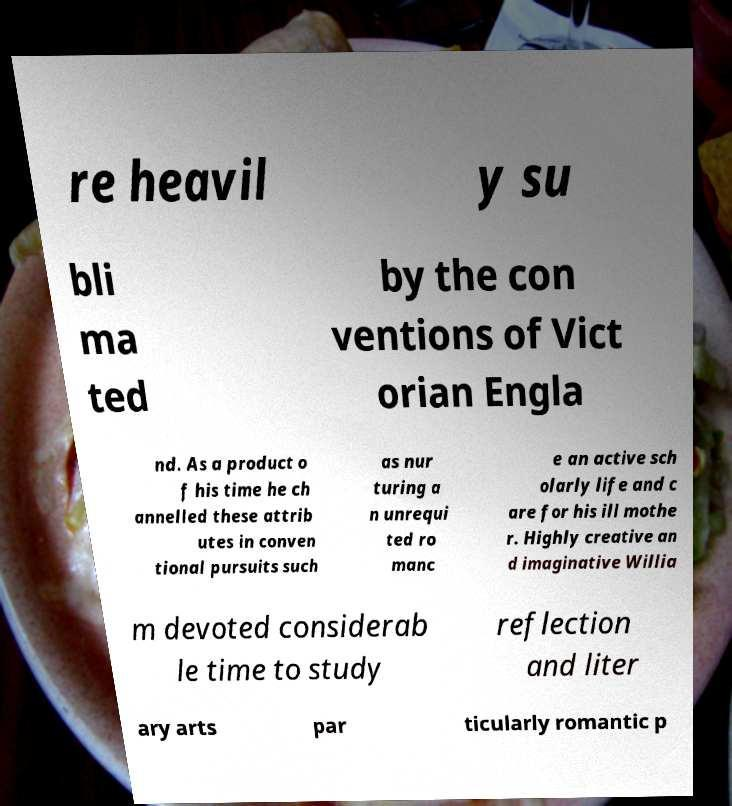Could you assist in decoding the text presented in this image and type it out clearly? re heavil y su bli ma ted by the con ventions of Vict orian Engla nd. As a product o f his time he ch annelled these attrib utes in conven tional pursuits such as nur turing a n unrequi ted ro manc e an active sch olarly life and c are for his ill mothe r. Highly creative an d imaginative Willia m devoted considerab le time to study reflection and liter ary arts par ticularly romantic p 